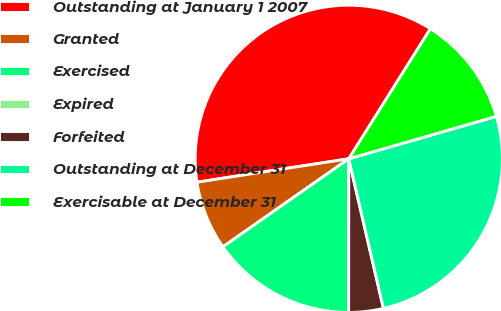Convert chart. <chart><loc_0><loc_0><loc_500><loc_500><pie_chart><fcel>Outstanding at January 1 2007<fcel>Granted<fcel>Exercised<fcel>Expired<fcel>Forfeited<fcel>Outstanding at December 31<fcel>Exercisable at December 31<nl><fcel>36.36%<fcel>7.28%<fcel>15.26%<fcel>0.01%<fcel>3.64%<fcel>25.83%<fcel>11.62%<nl></chart> 